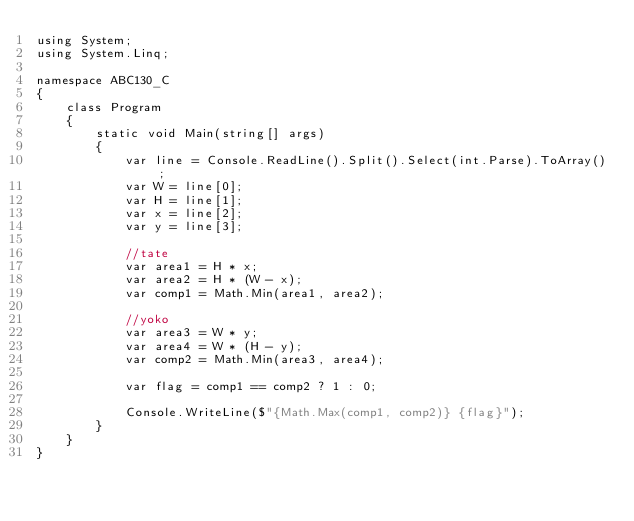Convert code to text. <code><loc_0><loc_0><loc_500><loc_500><_C#_>using System;
using System.Linq;

namespace ABC130_C
{
    class Program
    {
        static void Main(string[] args)
        {
            var line = Console.ReadLine().Split().Select(int.Parse).ToArray();
            var W = line[0];
            var H = line[1];
            var x = line[2];
            var y = line[3];

            //tate
            var area1 = H * x;
            var area2 = H * (W - x);
            var comp1 = Math.Min(area1, area2);

            //yoko
            var area3 = W * y;
            var area4 = W * (H - y);
            var comp2 = Math.Min(area3, area4);

            var flag = comp1 == comp2 ? 1 : 0;

            Console.WriteLine($"{Math.Max(comp1, comp2)} {flag}");
        }
    }
}
</code> 